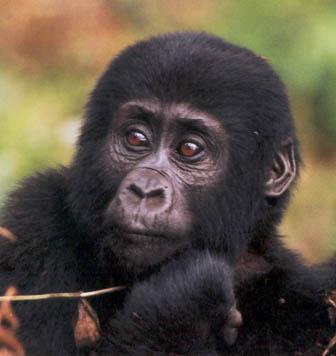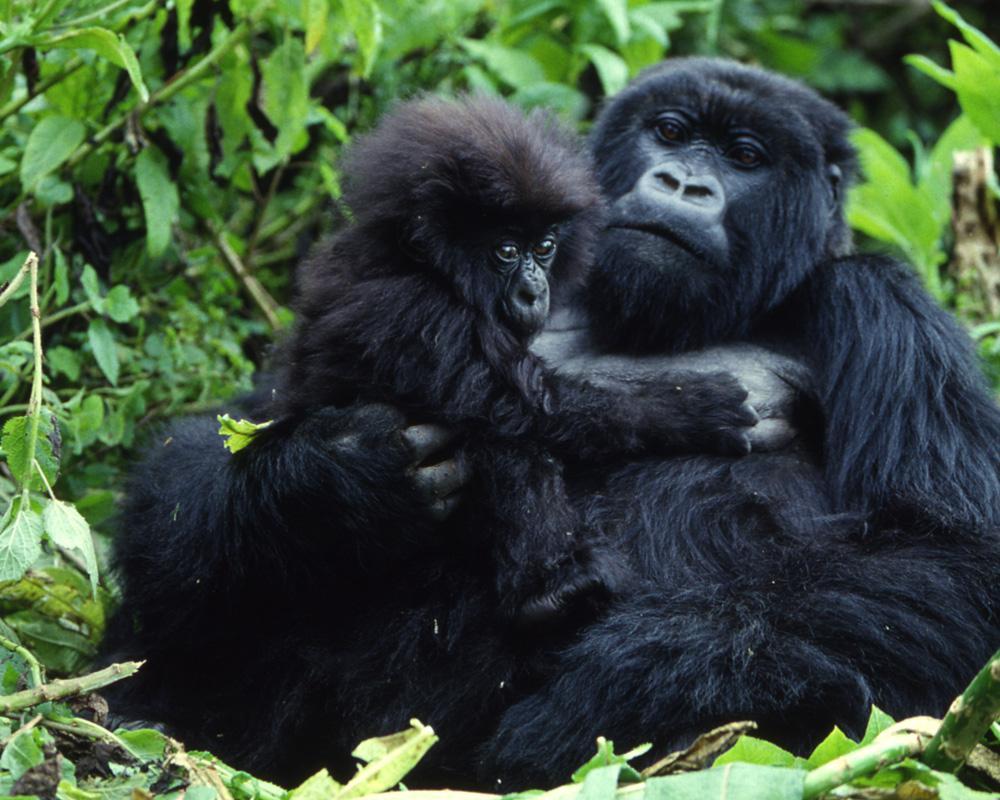The first image is the image on the left, the second image is the image on the right. Analyze the images presented: Is the assertion "Right image shows a young gorilla held on the chest of an adult gorilla, surrounded by foliage." valid? Answer yes or no. Yes. The first image is the image on the left, the second image is the image on the right. For the images shown, is this caption "At least one baby gorilla is cuddled up with it's mother." true? Answer yes or no. Yes. 